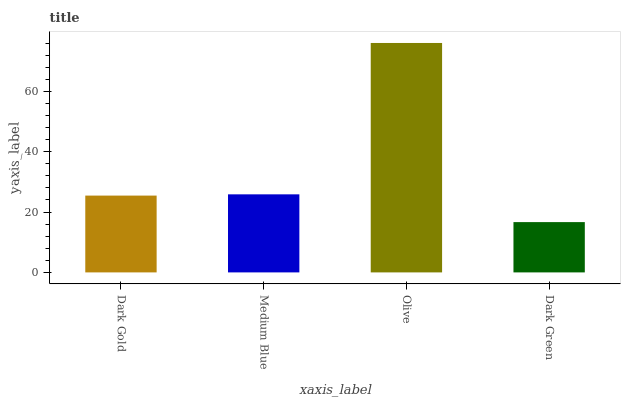Is Dark Green the minimum?
Answer yes or no. Yes. Is Olive the maximum?
Answer yes or no. Yes. Is Medium Blue the minimum?
Answer yes or no. No. Is Medium Blue the maximum?
Answer yes or no. No. Is Medium Blue greater than Dark Gold?
Answer yes or no. Yes. Is Dark Gold less than Medium Blue?
Answer yes or no. Yes. Is Dark Gold greater than Medium Blue?
Answer yes or no. No. Is Medium Blue less than Dark Gold?
Answer yes or no. No. Is Medium Blue the high median?
Answer yes or no. Yes. Is Dark Gold the low median?
Answer yes or no. Yes. Is Dark Gold the high median?
Answer yes or no. No. Is Olive the low median?
Answer yes or no. No. 